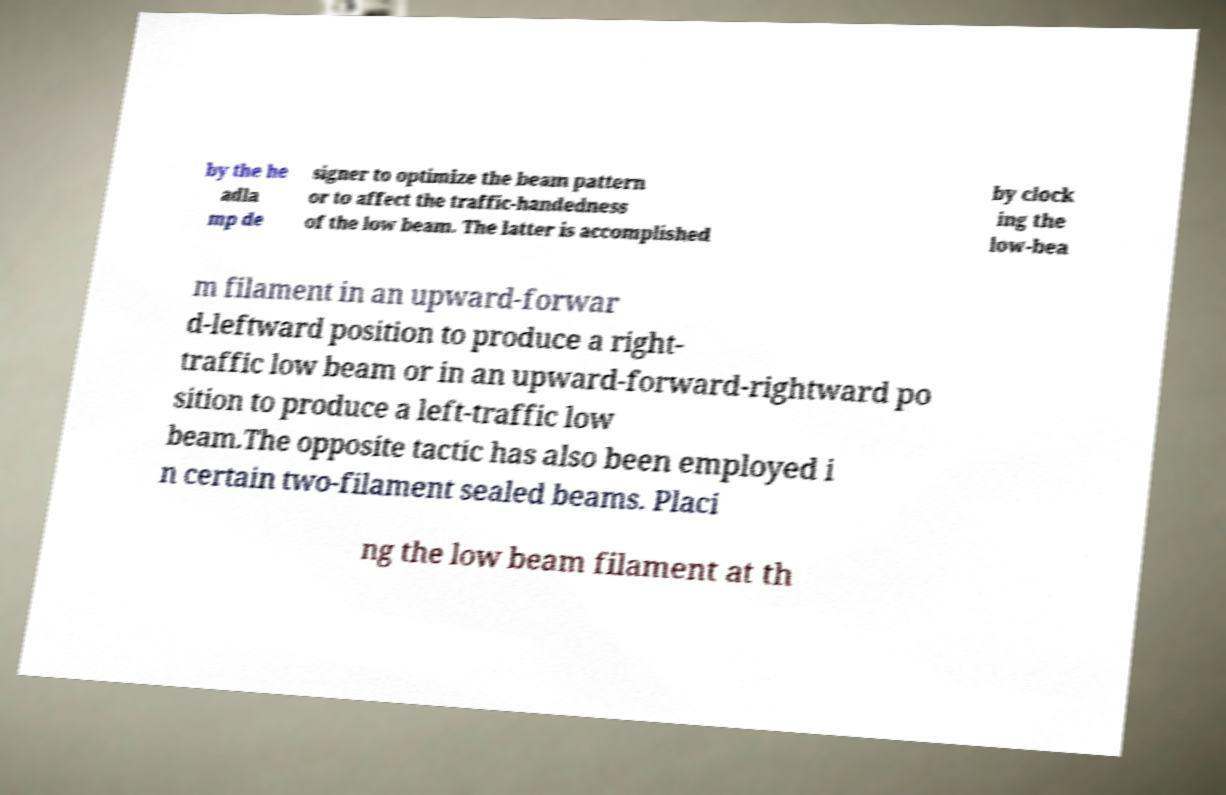Please identify and transcribe the text found in this image. by the he adla mp de signer to optimize the beam pattern or to affect the traffic-handedness of the low beam. The latter is accomplished by clock ing the low-bea m filament in an upward-forwar d-leftward position to produce a right- traffic low beam or in an upward-forward-rightward po sition to produce a left-traffic low beam.The opposite tactic has also been employed i n certain two-filament sealed beams. Placi ng the low beam filament at th 